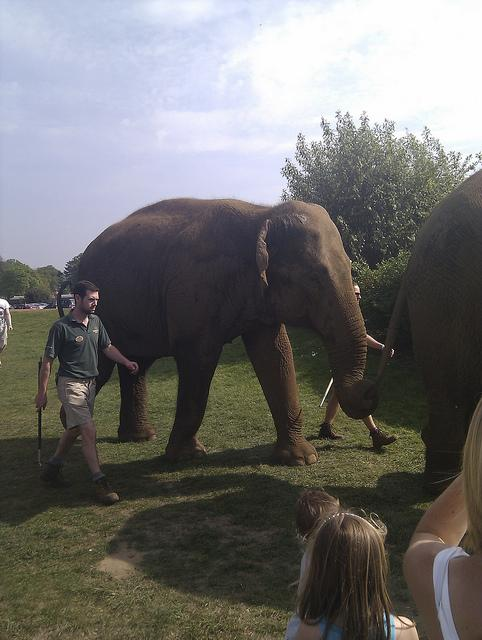What is the woman in white shirt likely to be doing?

Choices:
A) covering face
B) feeding
C) taking photo
D) waving taking photo 